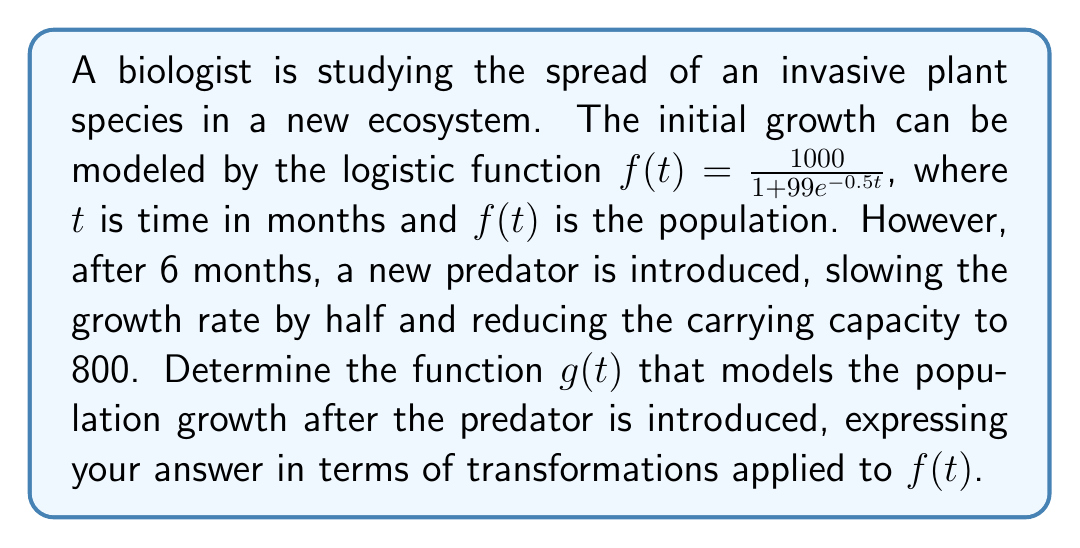What is the answer to this math problem? To solve this problem, we need to apply several transformations to the original function $f(t)$:

1. Time shift: The new function should start 6 months after the original, so we need to replace $t$ with $(t-6)$.

2. Vertical stretch: The growth rate is halved, which means we need to multiply the exponential term by 2 inside the function. This is equivalent to multiplying the entire function by $\frac{1}{2}$.

3. Vertical stretch and shift: To reduce the carrying capacity from 1000 to 800, we need to multiply the function by $\frac{4}{5}$ (since $800 = \frac{4}{5} \cdot 1000$).

Let's apply these transformations step by step:

a) Time shift: $f(t-6) = \frac{1000}{1 + 99e^{-0.5(t-6)}}$

b) Halving the growth rate: $\frac{1}{2}f(t-6) = \frac{500}{1 + 99e^{-0.5(t-6)}}$

c) Adjusting the carrying capacity: $\frac{4}{5} \cdot \frac{1}{2}f(t-6) = \frac{400}{1 + 99e^{-0.5(t-6)}}$

Therefore, the final transformed function $g(t)$ can be expressed as:

$$g(t) = \frac{4}{5} \cdot \frac{1}{2}f(t-6) = \frac{400}{1 + 99e^{-0.5(t-6)}}$$

This function represents the population growth model after the predator is introduced, incorporating the time shift, reduced growth rate, and lower carrying capacity.
Answer: $g(t) = \frac{4}{5} \cdot \frac{1}{2}f(t-6)$ 